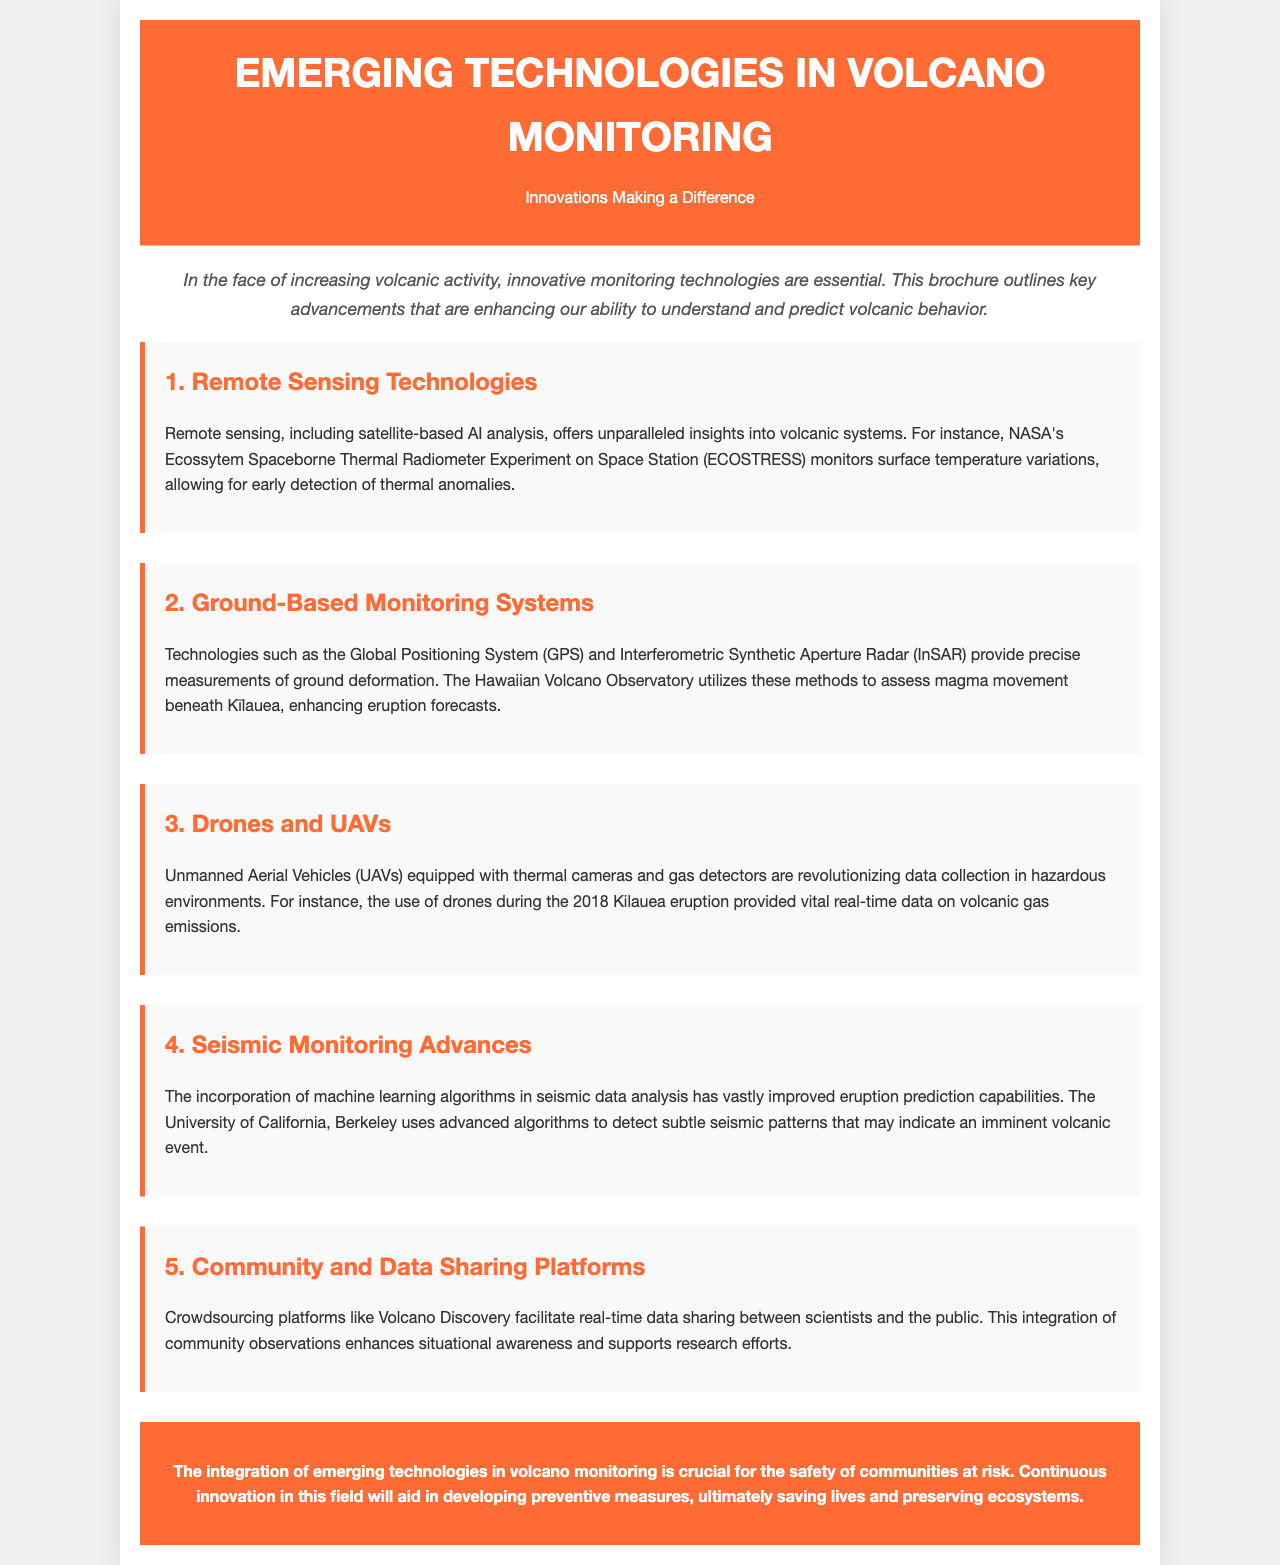What is the title of the brochure? The title is prominently displayed in the header of the document.
Answer: Emerging Technologies in Volcano Monitoring What technology monitors surface temperature variations? This information is found under the section on Remote Sensing Technologies.
Answer: ECOSTRESS Which monitoring method uses GPS and InSAR? The document outlines these methods in the Ground-Based Monitoring Systems section.
Answer: Ground-Based Monitoring Systems What was used to collect data during the 2018 Kilauea eruption? The document provides this information in the Drones and UAVs section.
Answer: Drones Which institution uses machine learning for seismic data analysis? The name of the institution is mentioned in the Seismic Monitoring Advances section.
Answer: University of California, Berkeley What do crowdsourcing platforms like Volcano Discovery enhance? This is explained in the Community and Data Sharing Platforms section.
Answer: Situational awareness How many sections are there in the document? By counting the main sections listed in the document, we determine the total.
Answer: Five What color is used for section headers? The specific style for section headers is noted throughout the document.
Answer: #FF6B35 